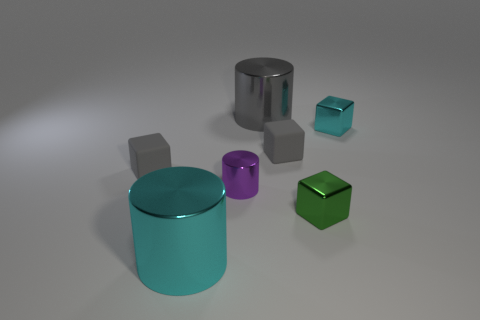Is there a yellow matte cylinder of the same size as the cyan metal block?
Your answer should be compact. No. How many objects are either gray things right of the gray metal thing or objects left of the gray cylinder?
Your answer should be compact. 4. What color is the tiny block in front of the gray thing that is left of the large cyan cylinder?
Keep it short and to the point. Green. There is another cube that is the same material as the cyan cube; what is its color?
Offer a very short reply. Green. What number of tiny matte objects have the same color as the tiny shiny cylinder?
Keep it short and to the point. 0. What number of objects are either big red metal spheres or cylinders?
Make the answer very short. 3. What shape is the gray thing that is the same size as the cyan metallic cylinder?
Provide a short and direct response. Cylinder. How many tiny objects are left of the small cyan shiny cube and behind the tiny purple object?
Ensure brevity in your answer.  2. What is the cyan thing to the right of the big gray cylinder made of?
Make the answer very short. Metal. There is a cyan cylinder that is made of the same material as the small cyan block; what is its size?
Provide a succinct answer. Large. 